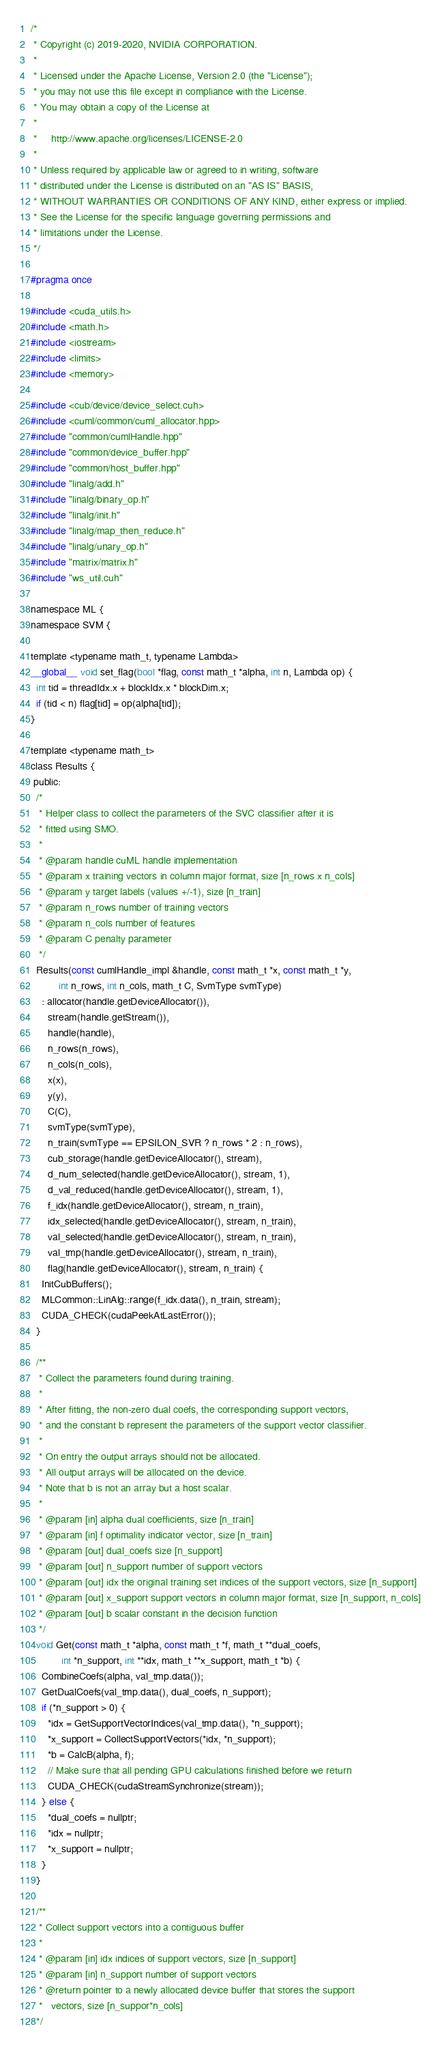Convert code to text. <code><loc_0><loc_0><loc_500><loc_500><_Cuda_>/*
 * Copyright (c) 2019-2020, NVIDIA CORPORATION.
 *
 * Licensed under the Apache License, Version 2.0 (the "License");
 * you may not use this file except in compliance with the License.
 * You may obtain a copy of the License at
 *
 *     http://www.apache.org/licenses/LICENSE-2.0
 *
 * Unless required by applicable law or agreed to in writing, software
 * distributed under the License is distributed on an "AS IS" BASIS,
 * WITHOUT WARRANTIES OR CONDITIONS OF ANY KIND, either express or implied.
 * See the License for the specific language governing permissions and
 * limitations under the License.
 */

#pragma once

#include <cuda_utils.h>
#include <math.h>
#include <iostream>
#include <limits>
#include <memory>

#include <cub/device/device_select.cuh>
#include <cuml/common/cuml_allocator.hpp>
#include "common/cumlHandle.hpp"
#include "common/device_buffer.hpp"
#include "common/host_buffer.hpp"
#include "linalg/add.h"
#include "linalg/binary_op.h"
#include "linalg/init.h"
#include "linalg/map_then_reduce.h"
#include "linalg/unary_op.h"
#include "matrix/matrix.h"
#include "ws_util.cuh"

namespace ML {
namespace SVM {

template <typename math_t, typename Lambda>
__global__ void set_flag(bool *flag, const math_t *alpha, int n, Lambda op) {
  int tid = threadIdx.x + blockIdx.x * blockDim.x;
  if (tid < n) flag[tid] = op(alpha[tid]);
}

template <typename math_t>
class Results {
 public:
  /*
   * Helper class to collect the parameters of the SVC classifier after it is
   * fitted using SMO.
   *
   * @param handle cuML handle implementation
   * @param x training vectors in column major format, size [n_rows x n_cols]
   * @param y target labels (values +/-1), size [n_train]
   * @param n_rows number of training vectors
   * @param n_cols number of features
   * @param C penalty parameter
   */
  Results(const cumlHandle_impl &handle, const math_t *x, const math_t *y,
          int n_rows, int n_cols, math_t C, SvmType svmType)
    : allocator(handle.getDeviceAllocator()),
      stream(handle.getStream()),
      handle(handle),
      n_rows(n_rows),
      n_cols(n_cols),
      x(x),
      y(y),
      C(C),
      svmType(svmType),
      n_train(svmType == EPSILON_SVR ? n_rows * 2 : n_rows),
      cub_storage(handle.getDeviceAllocator(), stream),
      d_num_selected(handle.getDeviceAllocator(), stream, 1),
      d_val_reduced(handle.getDeviceAllocator(), stream, 1),
      f_idx(handle.getDeviceAllocator(), stream, n_train),
      idx_selected(handle.getDeviceAllocator(), stream, n_train),
      val_selected(handle.getDeviceAllocator(), stream, n_train),
      val_tmp(handle.getDeviceAllocator(), stream, n_train),
      flag(handle.getDeviceAllocator(), stream, n_train) {
    InitCubBuffers();
    MLCommon::LinAlg::range(f_idx.data(), n_train, stream);
    CUDA_CHECK(cudaPeekAtLastError());
  }

  /**
   * Collect the parameters found during training.
   *
   * After fitting, the non-zero dual coefs, the corresponding support vectors,
   * and the constant b represent the parameters of the support vector classifier.
   *
   * On entry the output arrays should not be allocated.
   * All output arrays will be allocated on the device.
   * Note that b is not an array but a host scalar.
   *
   * @param [in] alpha dual coefficients, size [n_train]
   * @param [in] f optimality indicator vector, size [n_train]
   * @param [out] dual_coefs size [n_support]
   * @param [out] n_support number of support vectors
   * @param [out] idx the original training set indices of the support vectors, size [n_support]
   * @param [out] x_support support vectors in column major format, size [n_support, n_cols]
   * @param [out] b scalar constant in the decision function
   */
  void Get(const math_t *alpha, const math_t *f, math_t **dual_coefs,
           int *n_support, int **idx, math_t **x_support, math_t *b) {
    CombineCoefs(alpha, val_tmp.data());
    GetDualCoefs(val_tmp.data(), dual_coefs, n_support);
    if (*n_support > 0) {
      *idx = GetSupportVectorIndices(val_tmp.data(), *n_support);
      *x_support = CollectSupportVectors(*idx, *n_support);
      *b = CalcB(alpha, f);
      // Make sure that all pending GPU calculations finished before we return
      CUDA_CHECK(cudaStreamSynchronize(stream));
    } else {
      *dual_coefs = nullptr;
      *idx = nullptr;
      *x_support = nullptr;
    }
  }

  /**
   * Collect support vectors into a contiguous buffer
   *
   * @param [in] idx indices of support vectors, size [n_support]
   * @param [in] n_support number of support vectors
   * @return pointer to a newly allocated device buffer that stores the support
   *   vectors, size [n_suppor*n_cols]
  */</code> 